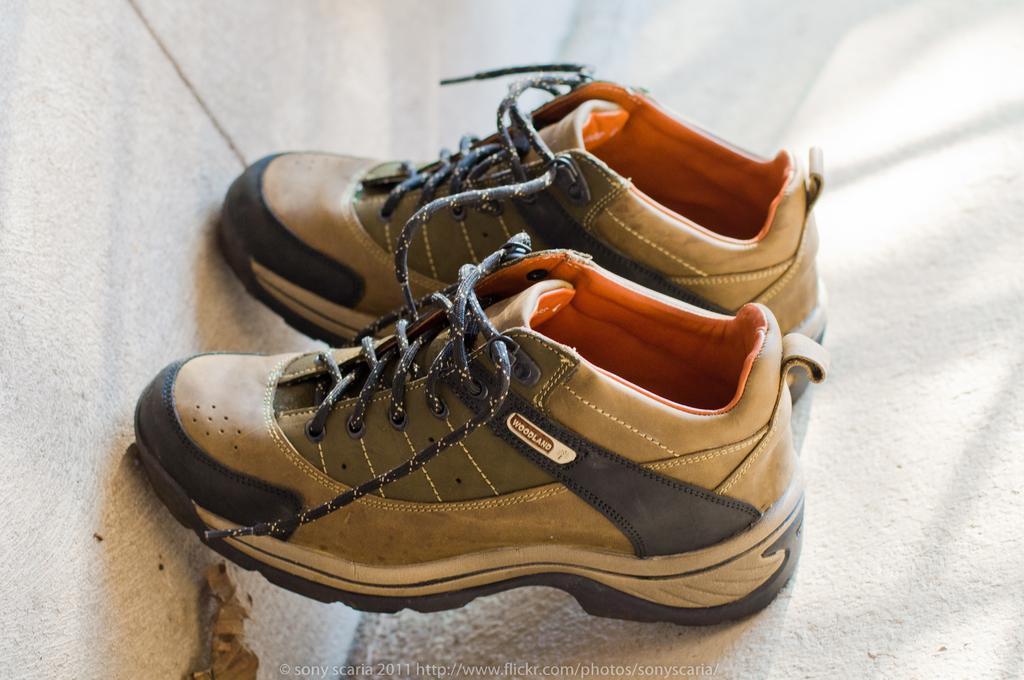Please provide a concise description of this image. In this image we can see the pair of woodland shoes on the surface. We can also see the wall, dried leaf and also the text at the bottom. 